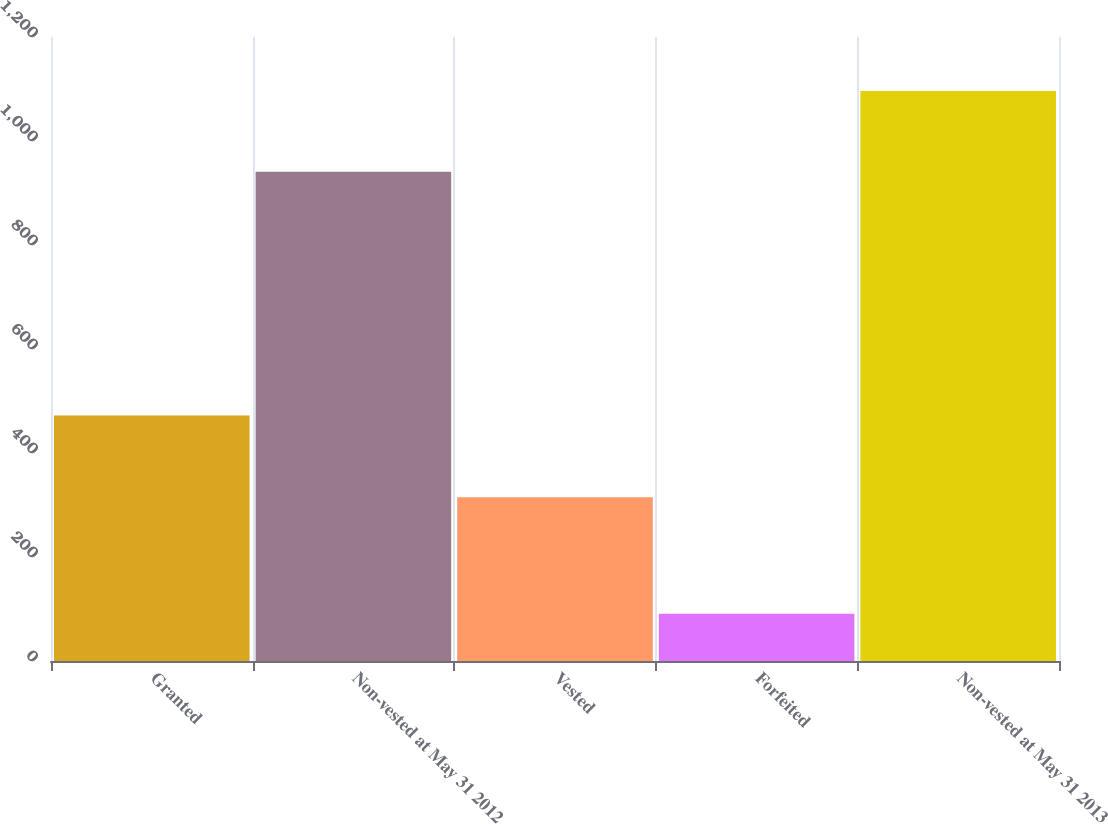<chart> <loc_0><loc_0><loc_500><loc_500><bar_chart><fcel>Granted<fcel>Non-vested at May 31 2012<fcel>Vested<fcel>Forfeited<fcel>Non-vested at May 31 2013<nl><fcel>472<fcel>941<fcel>315<fcel>91<fcel>1096<nl></chart> 